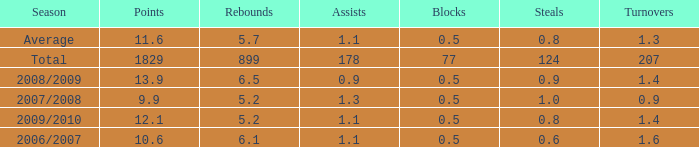What is the maximum rebounds when there are 0.9 steals and fewer than 1.4 turnovers? None. Would you be able to parse every entry in this table? {'header': ['Season', 'Points', 'Rebounds', 'Assists', 'Blocks', 'Steals', 'Turnovers'], 'rows': [['Average', '11.6', '5.7', '1.1', '0.5', '0.8', '1.3'], ['Total', '1829', '899', '178', '77', '124', '207'], ['2008/2009', '13.9', '6.5', '0.9', '0.5', '0.9', '1.4'], ['2007/2008', '9.9', '5.2', '1.3', '0.5', '1.0', '0.9'], ['2009/2010', '12.1', '5.2', '1.1', '0.5', '0.8', '1.4'], ['2006/2007', '10.6', '6.1', '1.1', '0.5', '0.6', '1.6']]} 